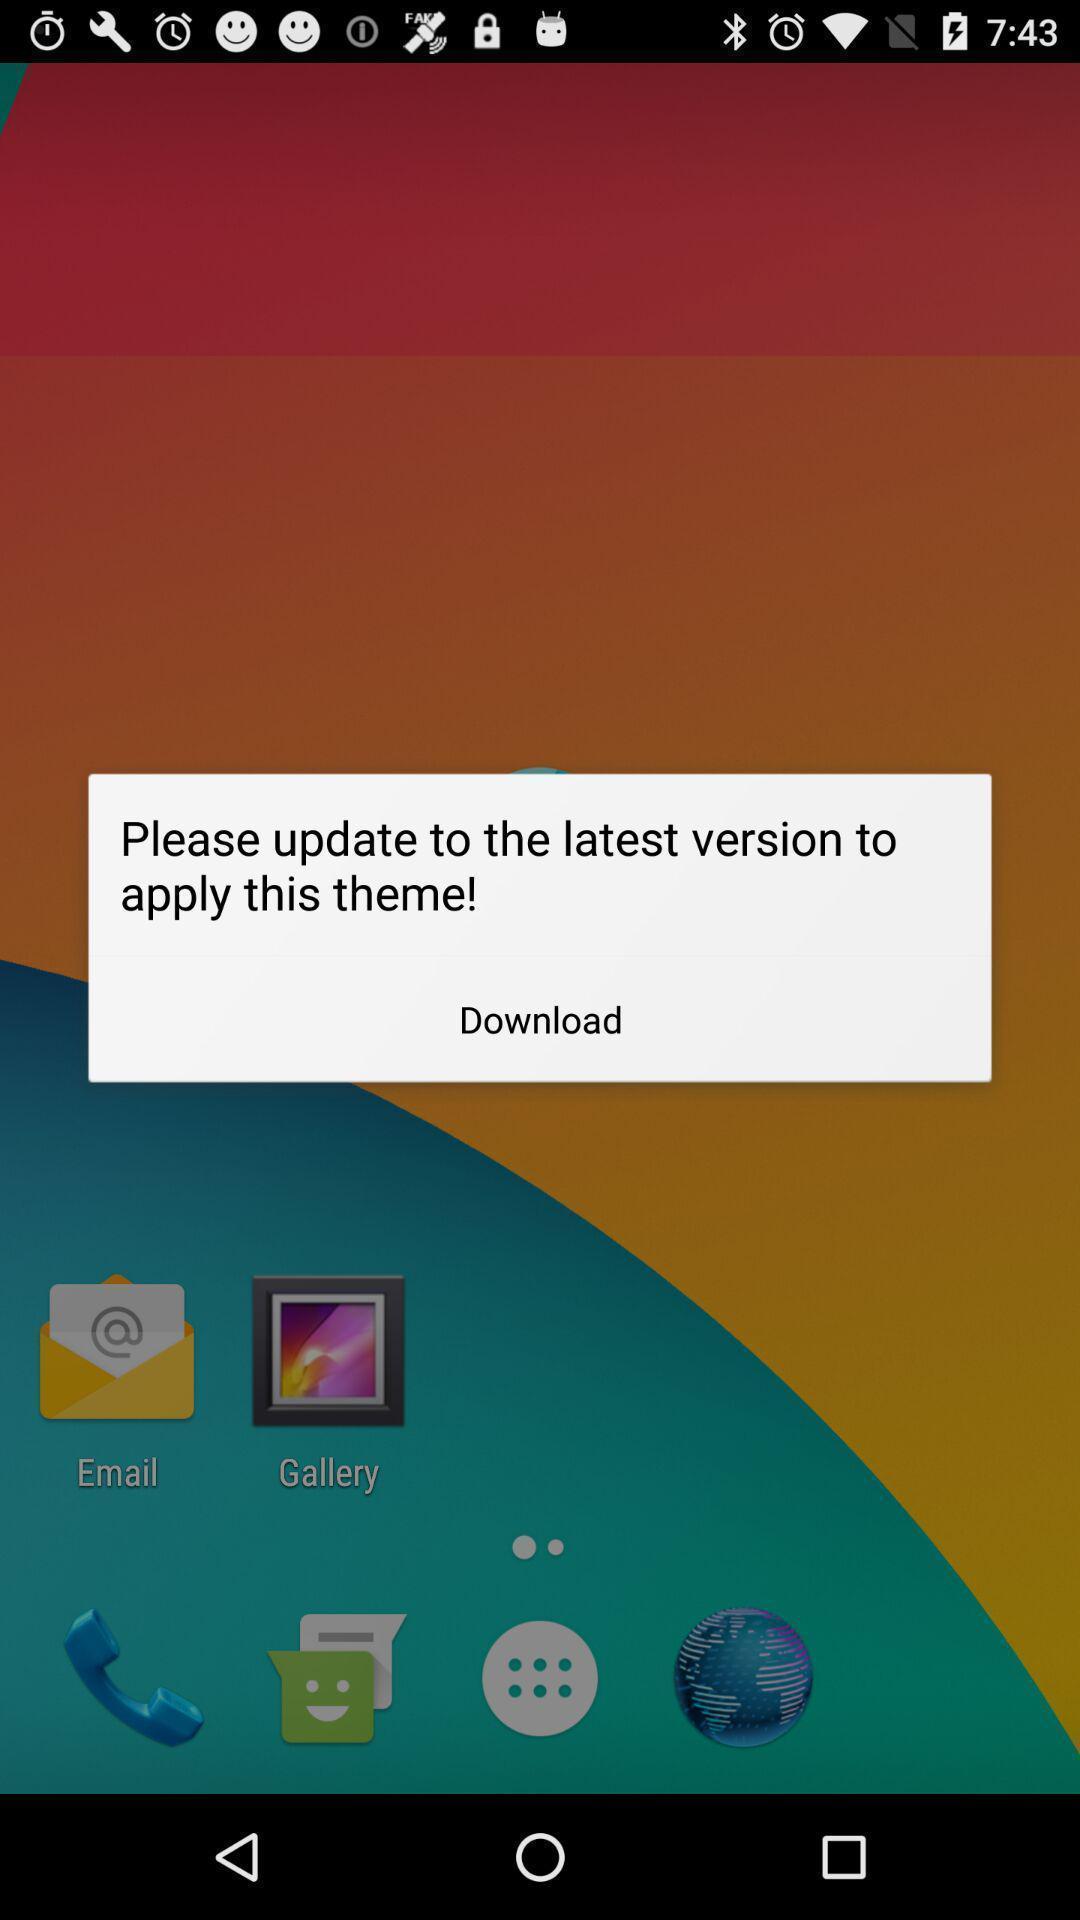Provide a description of this screenshot. Pop-up showing to update latest version. 